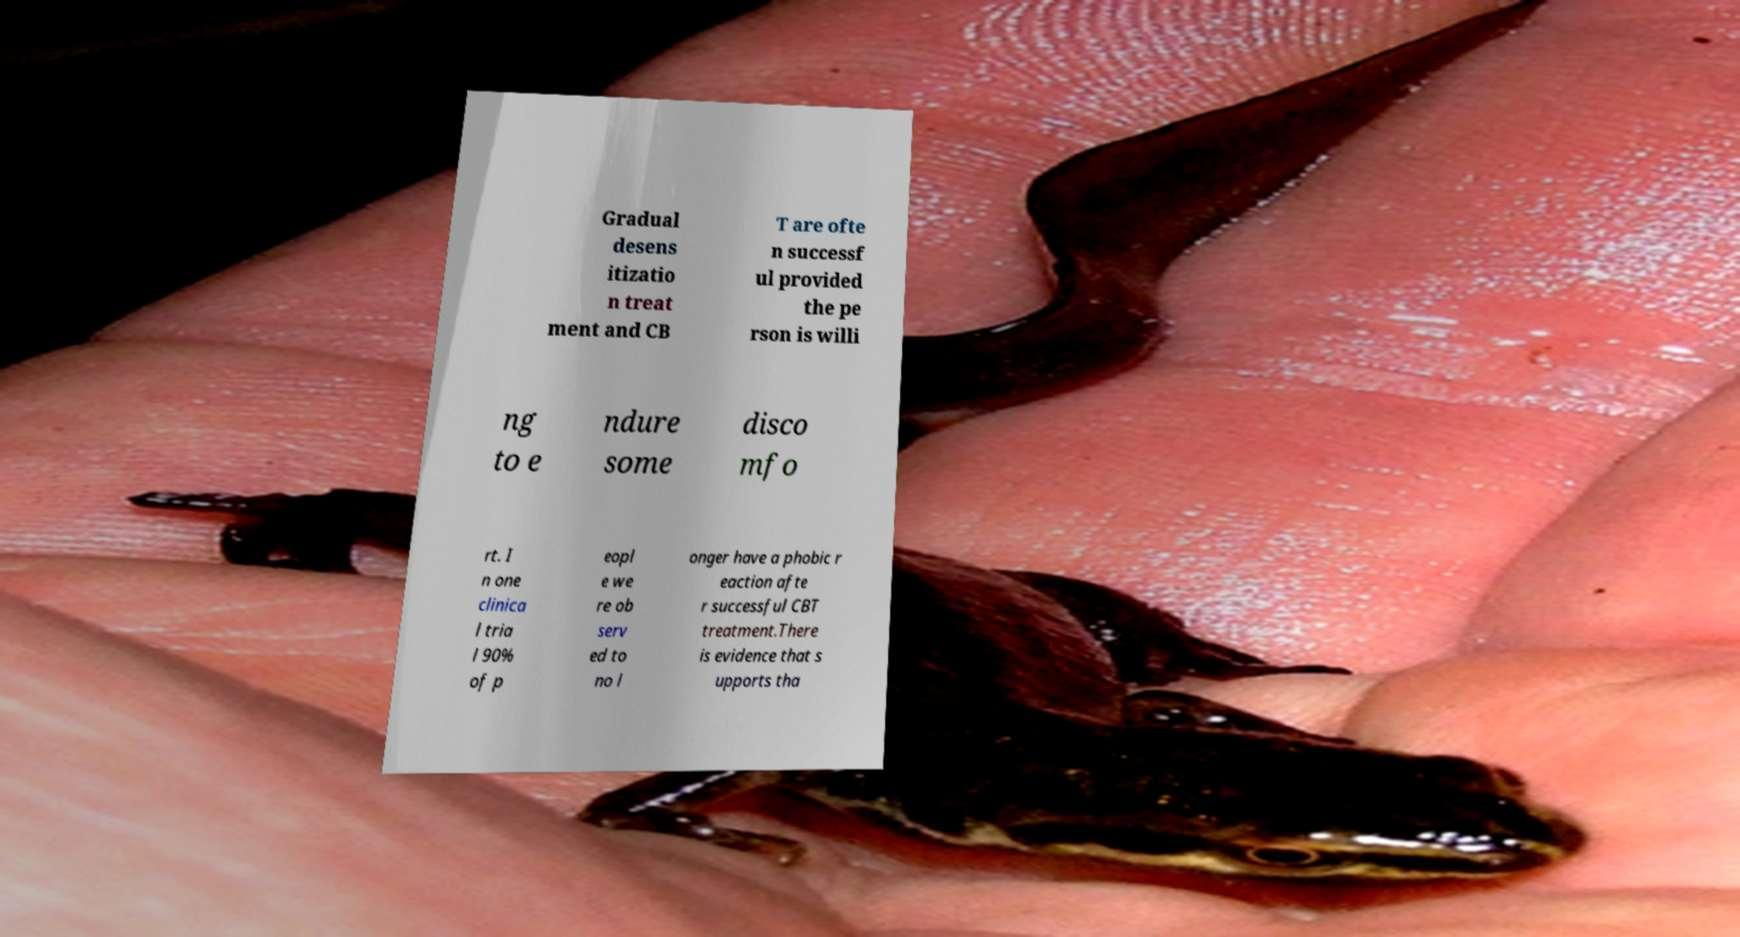Can you accurately transcribe the text from the provided image for me? Gradual desens itizatio n treat ment and CB T are ofte n successf ul provided the pe rson is willi ng to e ndure some disco mfo rt. I n one clinica l tria l 90% of p eopl e we re ob serv ed to no l onger have a phobic r eaction afte r successful CBT treatment.There is evidence that s upports tha 